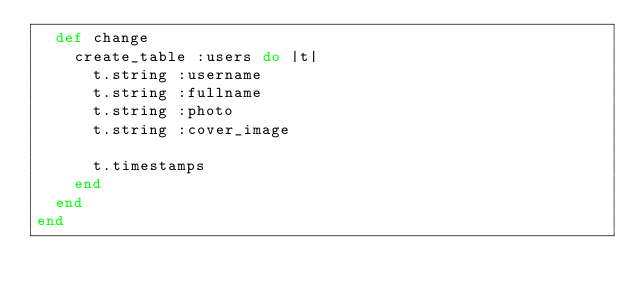<code> <loc_0><loc_0><loc_500><loc_500><_Ruby_>  def change
    create_table :users do |t|
      t.string :username
      t.string :fullname
      t.string :photo
      t.string :cover_image

      t.timestamps
    end
  end
end
</code> 